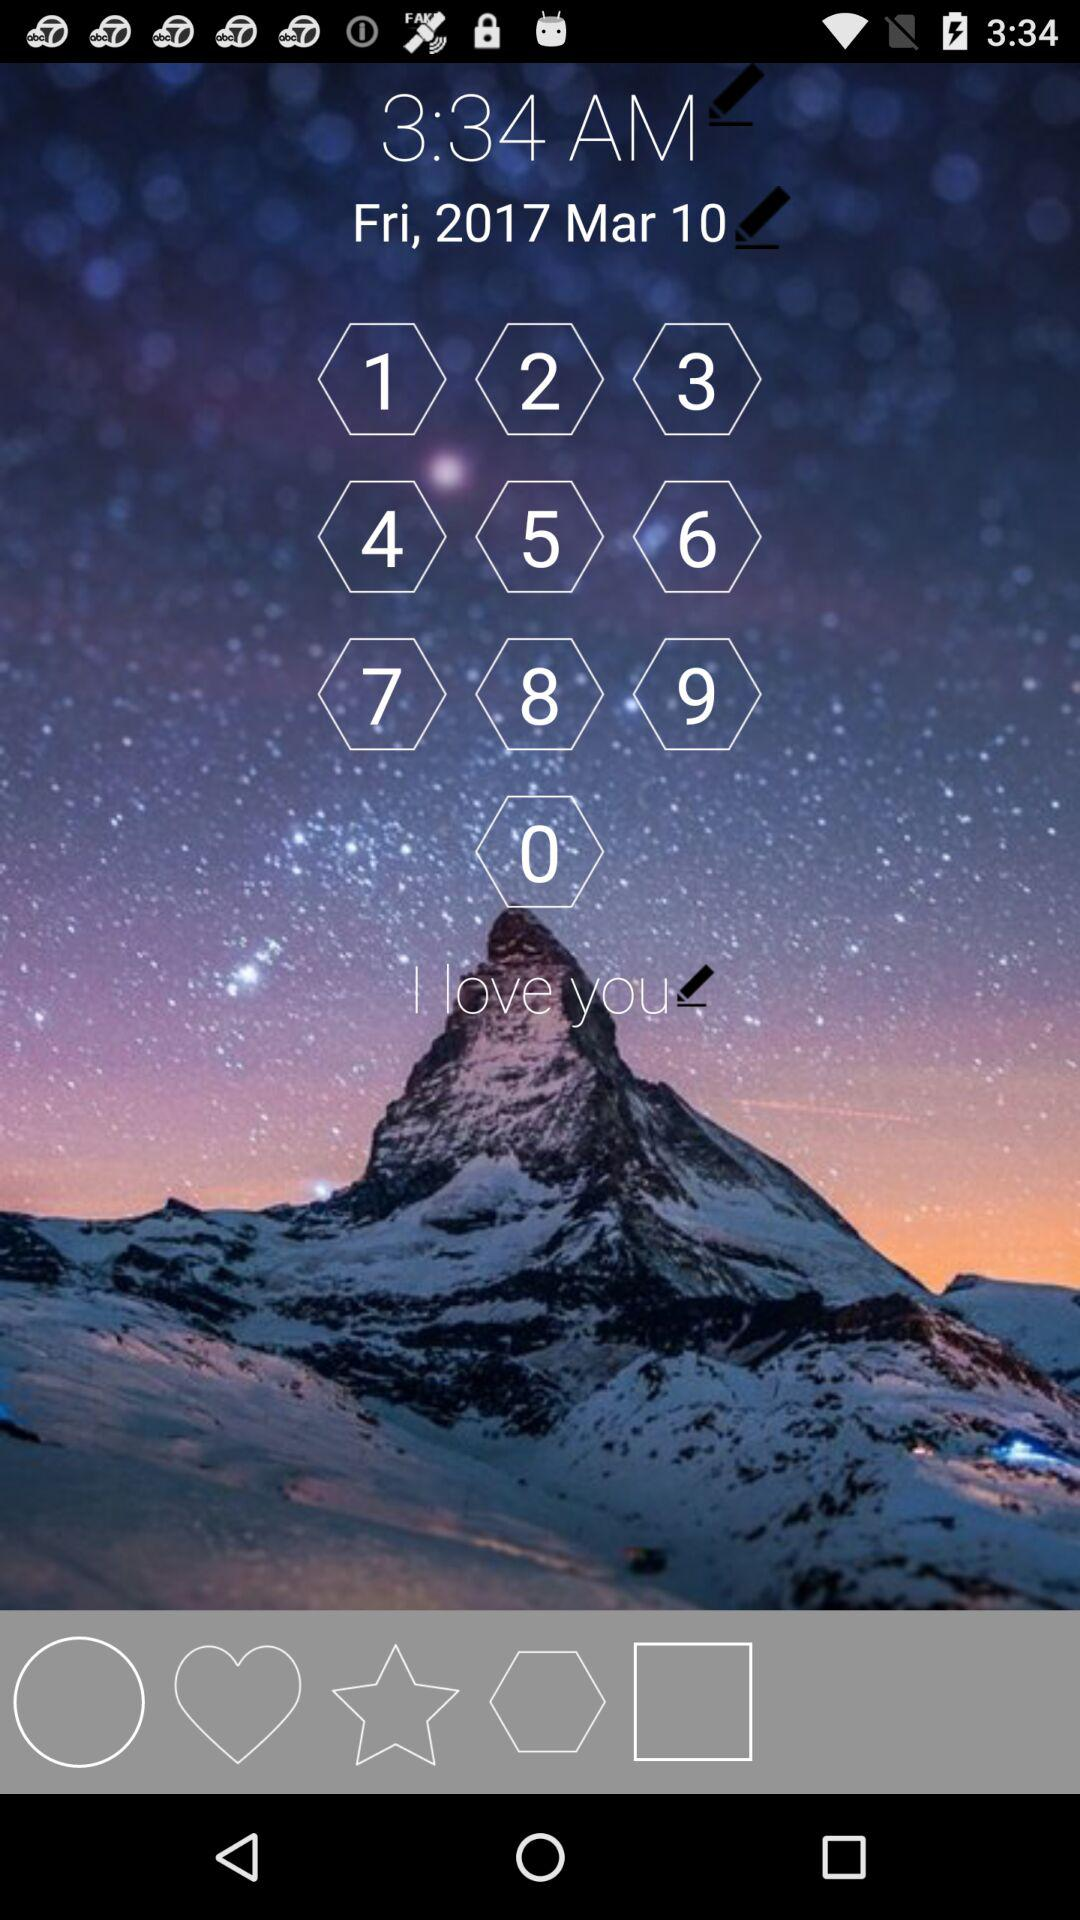What is the selected time? The selected time is 3:34 AM. 